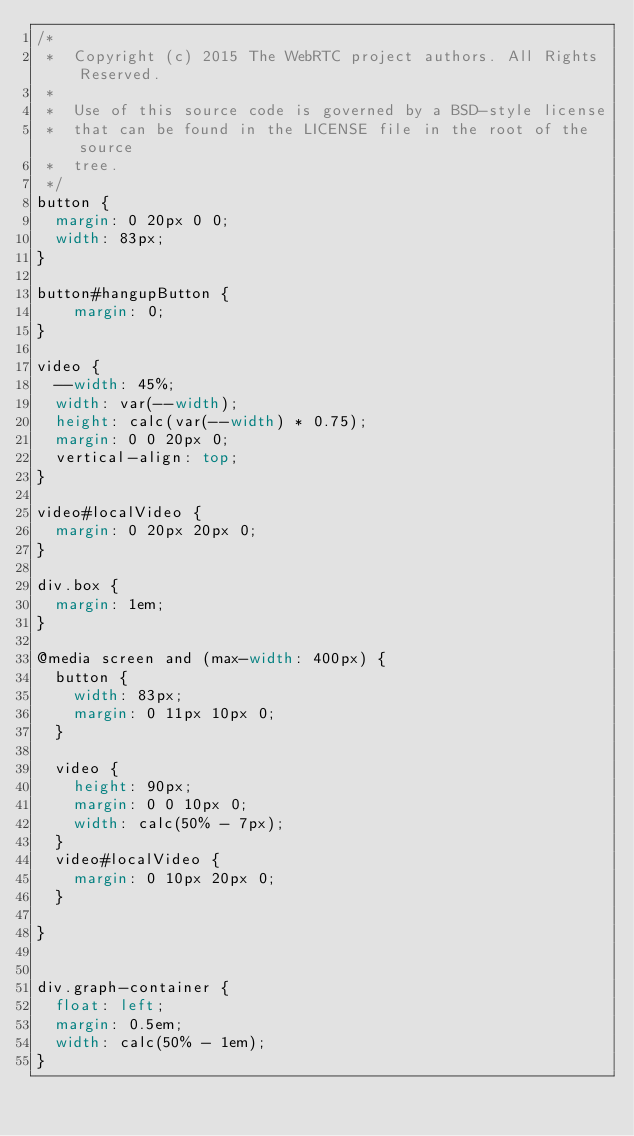<code> <loc_0><loc_0><loc_500><loc_500><_CSS_>/*
 *  Copyright (c) 2015 The WebRTC project authors. All Rights Reserved.
 *
 *  Use of this source code is governed by a BSD-style license
 *  that can be found in the LICENSE file in the root of the source
 *  tree.
 */
button {
  margin: 0 20px 0 0;
  width: 83px;
}

button#hangupButton {
    margin: 0;
}

video {
  --width: 45%;
  width: var(--width);
  height: calc(var(--width) * 0.75);
  margin: 0 0 20px 0;
  vertical-align: top;
}

video#localVideo {
  margin: 0 20px 20px 0;
}

div.box {
  margin: 1em;
}

@media screen and (max-width: 400px) {
  button {
    width: 83px;
    margin: 0 11px 10px 0;
  }

  video {
    height: 90px;
    margin: 0 0 10px 0;
    width: calc(50% - 7px);
  }
  video#localVideo {
    margin: 0 10px 20px 0;
  }

}


div.graph-container {
	float: left;
	margin: 0.5em;
	width: calc(50% - 1em);
}
</code> 